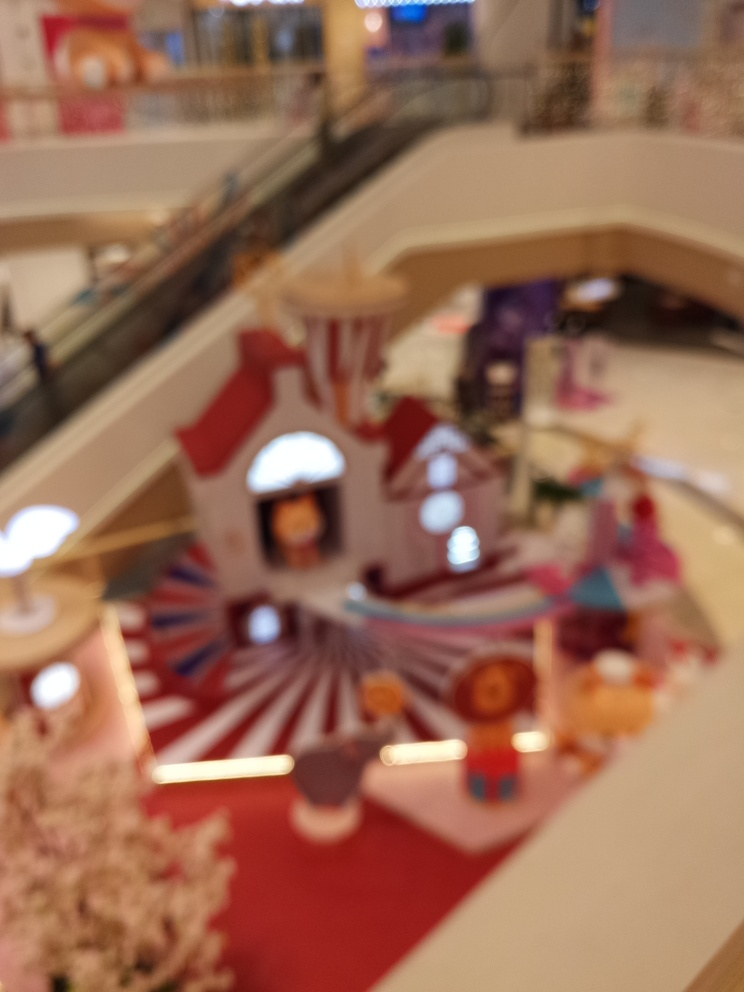Is the lighting sufficient in the image? It is challenging to assess the lighting conditions accurately due to the image being out of focus. However, from the visible bright areas and apparent lack of shadows, it seems like there might be a decent amount of light present. A clearer picture would be necessary for a definitive evaluation. 